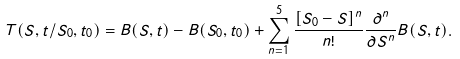<formula> <loc_0><loc_0><loc_500><loc_500>T ( S , t / S _ { 0 } , t _ { 0 } ) = B ( S , t ) - B ( S _ { 0 } , t _ { 0 } ) + \sum _ { n = 1 } ^ { 5 } \frac { [ S _ { 0 } - S ] ^ { n } } { n ! } \frac { \partial ^ { n } } { \partial S ^ { n } } B ( S , t ) .</formula> 